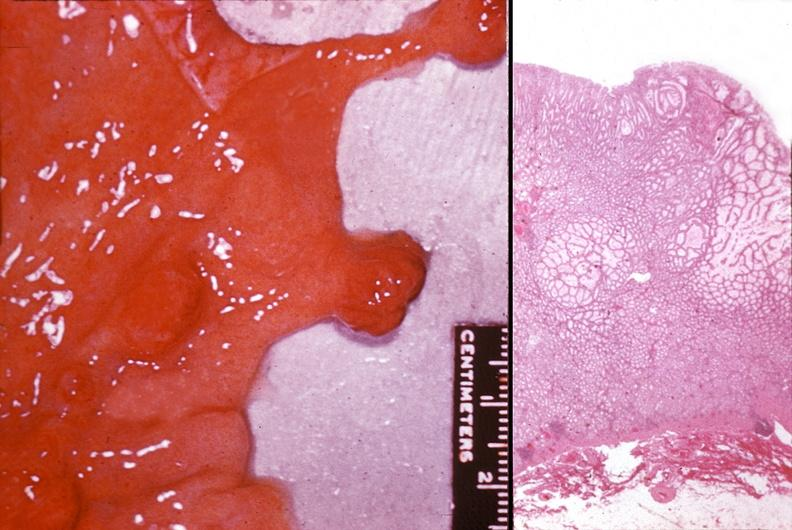s source present?
Answer the question using a single word or phrase. No 